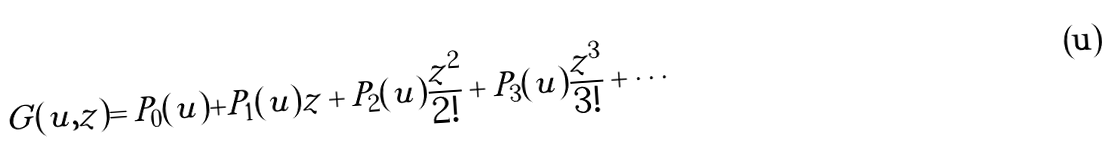Convert formula to latex. <formula><loc_0><loc_0><loc_500><loc_500>G ( u , z ) = P _ { 0 } ( u ) + P _ { 1 } ( u ) z + P _ { 2 } ( u ) \frac { z ^ { 2 } } { 2 ! } + P _ { 3 } ( u ) \frac { z ^ { 3 } } { 3 ! } + \cdots</formula> 